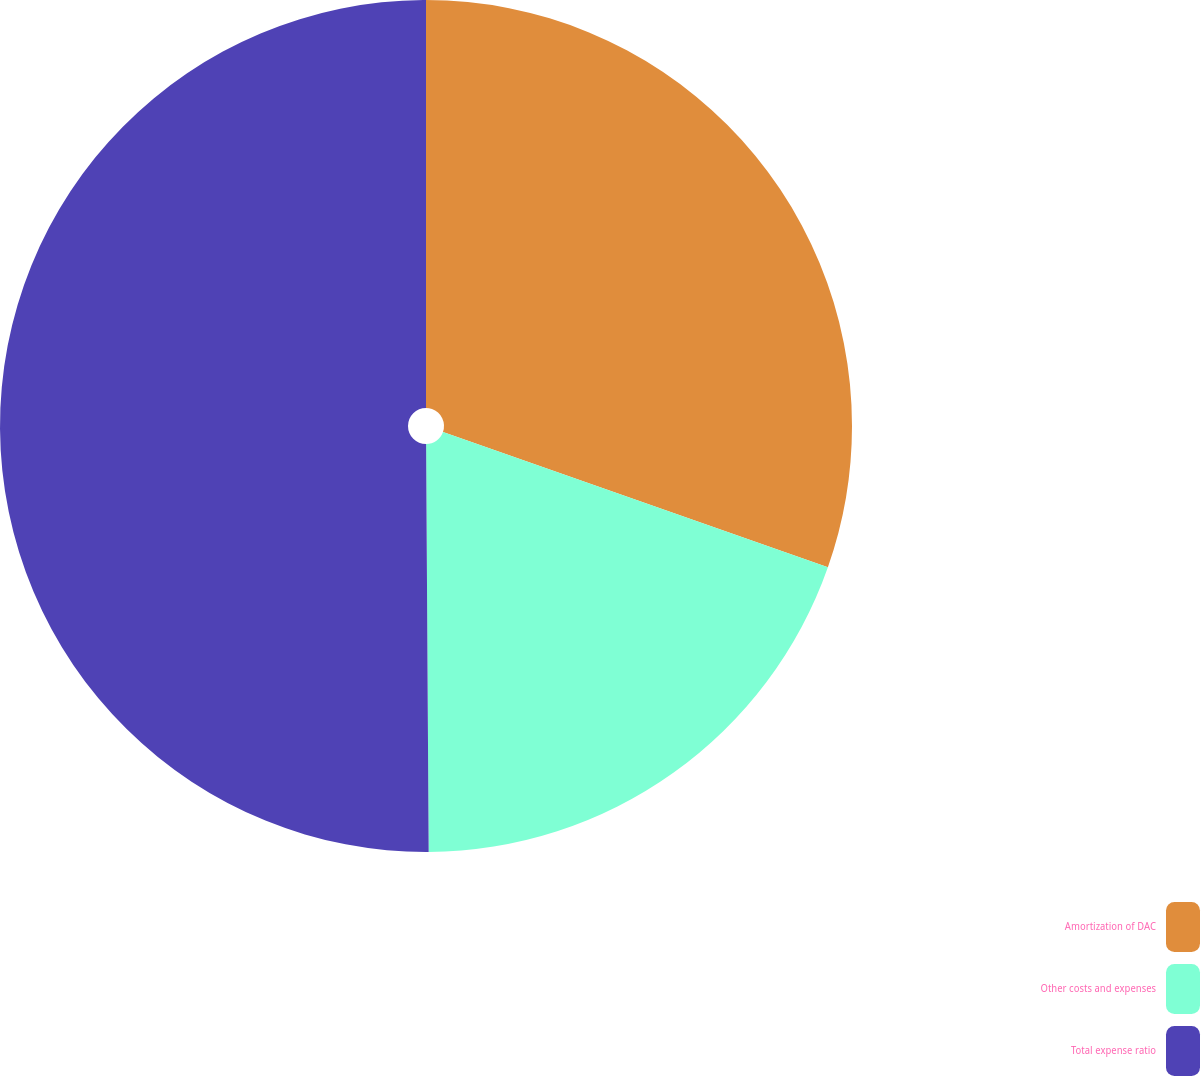Convert chart to OTSL. <chart><loc_0><loc_0><loc_500><loc_500><pie_chart><fcel>Amortization of DAC<fcel>Other costs and expenses<fcel>Total expense ratio<nl><fcel>30.38%<fcel>19.52%<fcel>50.1%<nl></chart> 